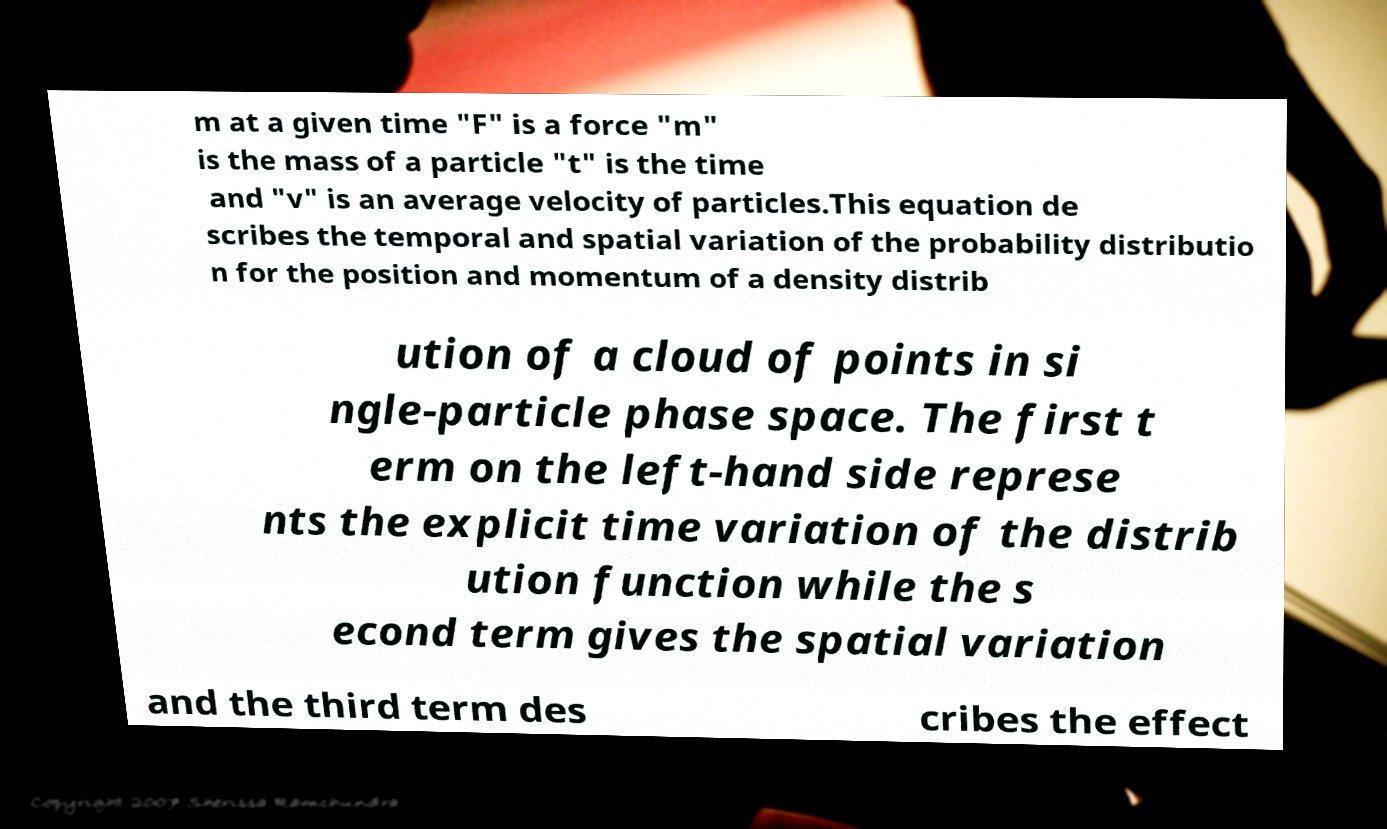Please read and relay the text visible in this image. What does it say? m at a given time "F" is a force "m" is the mass of a particle "t" is the time and "v" is an average velocity of particles.This equation de scribes the temporal and spatial variation of the probability distributio n for the position and momentum of a density distrib ution of a cloud of points in si ngle-particle phase space. The first t erm on the left-hand side represe nts the explicit time variation of the distrib ution function while the s econd term gives the spatial variation and the third term des cribes the effect 